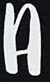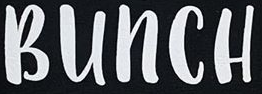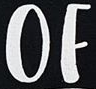Read the text from these images in sequence, separated by a semicolon. A; BUNCH; OF 